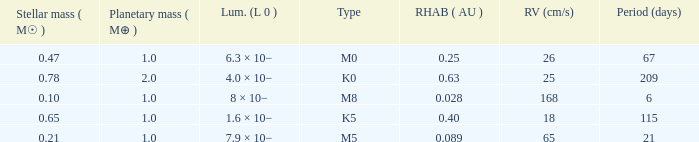What is the smallest period (days) to have a planetary mass of 1, a stellar mass greater than 0.21 and of the type M0? 67.0. Parse the table in full. {'header': ['Stellar mass ( M☉ )', 'Planetary mass ( M⊕ )', 'Lum. (L 0 )', 'Type', 'RHAB ( AU )', 'RV (cm/s)', 'Period (days)'], 'rows': [['0.47', '1.0', '6.3 × 10−', 'M0', '0.25', '26', '67'], ['0.78', '2.0', '4.0 × 10−', 'K0', '0.63', '25', '209'], ['0.10', '1.0', '8 × 10−', 'M8', '0.028', '168', '6'], ['0.65', '1.0', '1.6 × 10−', 'K5', '0.40', '18', '115'], ['0.21', '1.0', '7.9 × 10−', 'M5', '0.089', '65', '21']]} 